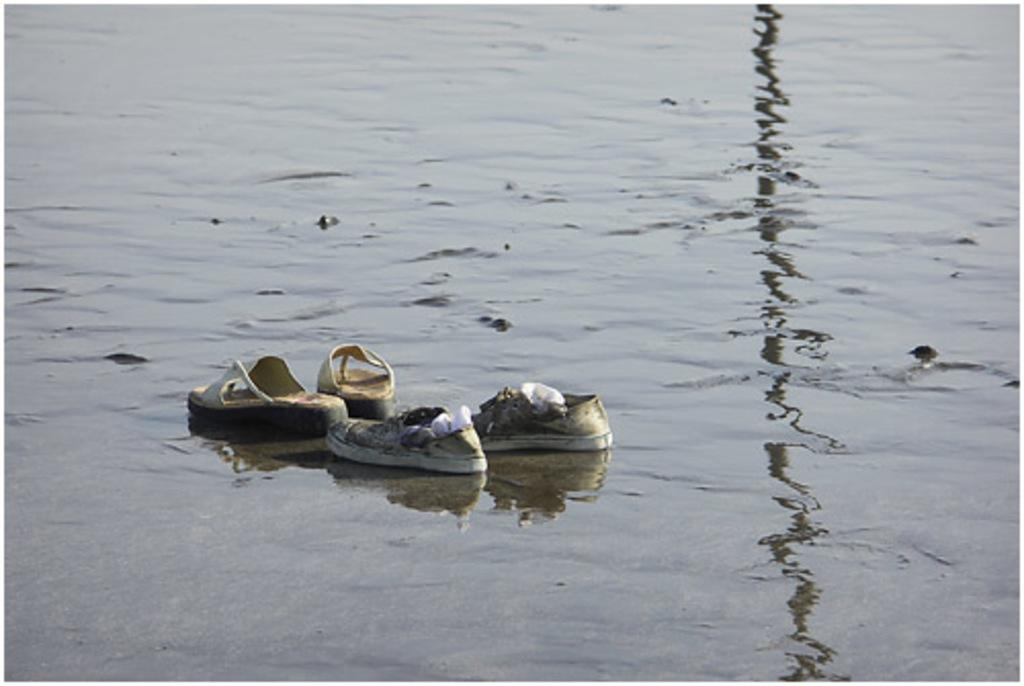What type of footwear can be seen on the water in the image? There are shoes and sandals on the water in the image. What type of clothing is inside the shoes? There are socks inside the shoes. How much rice is being cooked in the image? There is no rice or cooking activity present in the image. What type of fish can be seen swimming near the shoes? There are no fish present in the image. 